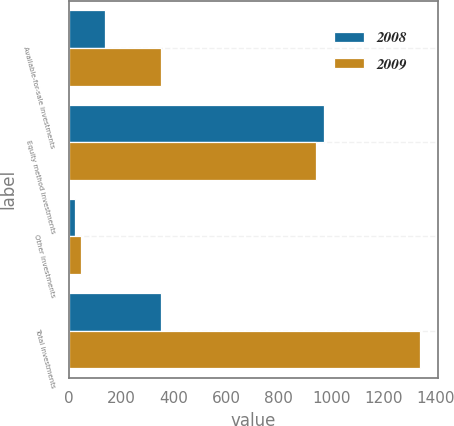Convert chart. <chart><loc_0><loc_0><loc_500><loc_500><stacked_bar_chart><ecel><fcel>Available-for-sale investments<fcel>Equity method investments<fcel>Other investments<fcel>Total investments<nl><fcel>2008<fcel>139<fcel>974<fcel>25<fcel>352<nl><fcel>2009<fcel>352<fcel>942<fcel>45<fcel>1339<nl></chart> 